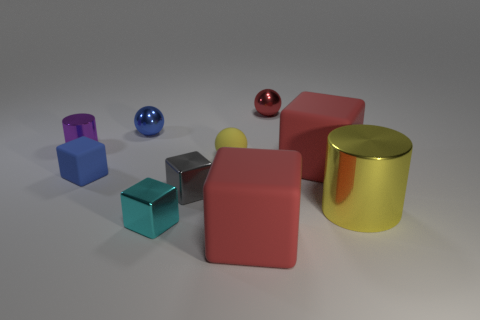Subtract all gray cubes. How many cubes are left? 4 Subtract all blue rubber cubes. How many cubes are left? 4 Subtract all purple blocks. Subtract all red balls. How many blocks are left? 5 Subtract all balls. How many objects are left? 7 Add 3 yellow cylinders. How many yellow cylinders are left? 4 Add 7 large brown spheres. How many large brown spheres exist? 7 Subtract 0 brown cylinders. How many objects are left? 10 Subtract all tiny cyan things. Subtract all big red things. How many objects are left? 7 